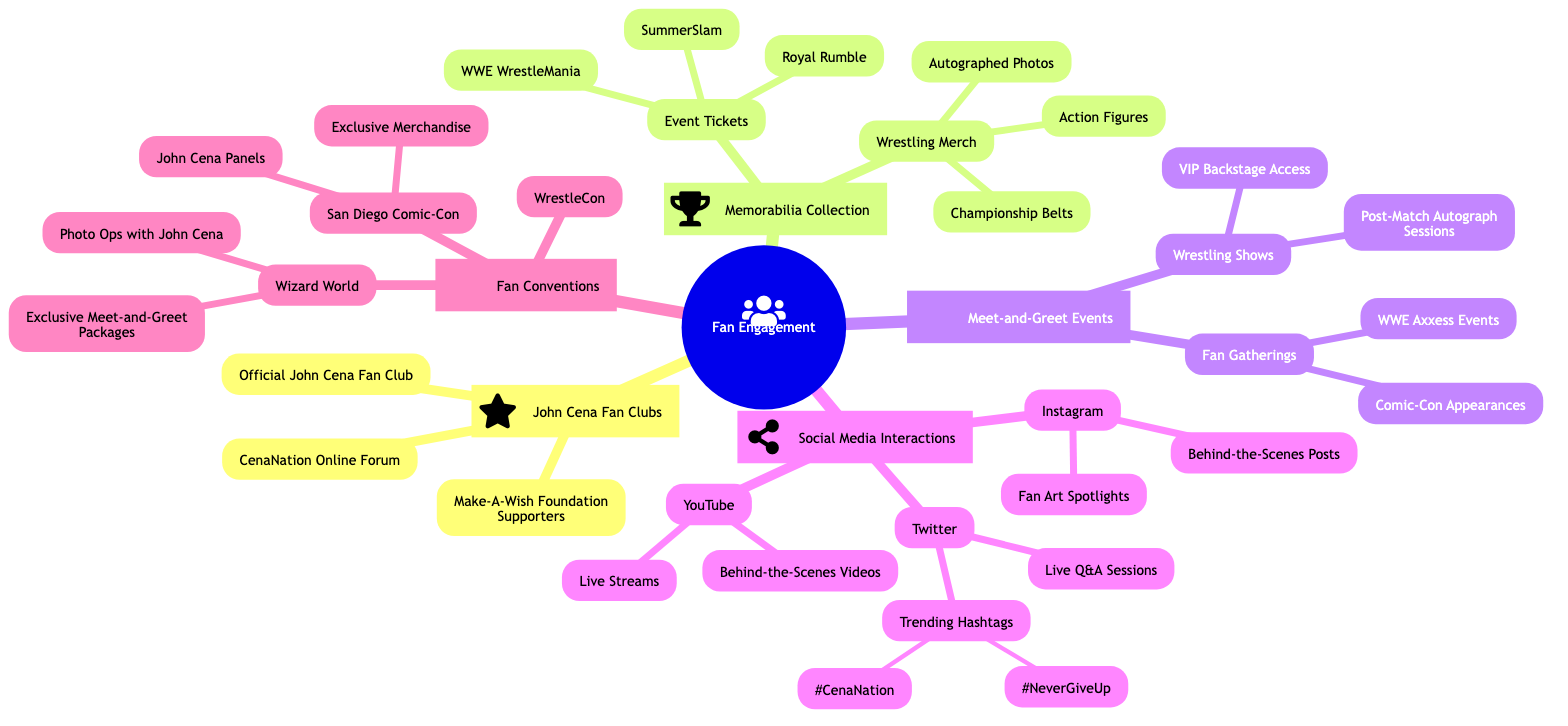What fan clubs are listed under John Cena? The diagram shows three fan clubs under the John Cena category. They are the Official John Cena Fan Club, Make-A-Wish Foundation Supporters, and CenaNation Online Forum. This can be identified by tracing from the main node "John Cena Fan Clubs" which branches out to these three nodes.
Answer: Official John Cena Fan Club, Make-A-Wish Foundation Supporters, CenaNation Online Forum How many types of memorabilia are listed? In the memorabilia section, there are two major categories: Wrestling Merch and Event Tickets. Each of these categories contains subcategories, but the distinct types of memorabilia are limited to these two. Hence, counting the main categories gives us the answer.
Answer: 2 What social media platform has the most interaction types? By analyzing the social media interactions section, we see that Twitter lists Live Q&A Sessions and Trending Hashtags, while Instagram has two distinct interaction types, and YouTube also has two. Therefore, Twitter has more variations compared to others.
Answer: Twitter Which event includes VIP Backstage Access? The diagram indicates that VIP Backstage Access is part of the Wrestling Shows under the Meet-and-Greet Events category. This can be determined by following the branches from the "Meet-and-Greet Events" which then leads down to "Wrestling Shows."
Answer: Wrestling Shows What are the trending hashtags listed? The specific hashtags in the Trending Hashtags section, found under Twitter, are #CenaNation and #NeverGiveUp. This information is contained in the last sub-node of the Twitter section.
Answer: #CenaNation, #NeverGiveUp How many events are included under Event Tickets? Under the Event Tickets category, there are three listed events: WWE WrestleMania, SummerSlam, and Royal Rumble. Counting these nodes gives us the total number of events in this section.
Answer: 3 What type of social media interaction is featured on Instagram? The diagram notes two types of interactions under Instagram: Behind-the-Scenes Posts and Fan Art Spotlights. Both of these are nested within the Instagram section, allowing easy identification.
Answer: Behind-the-Scenes Posts, Fan Art Spotlights Which convention has exclusive John Cena merchandise? The San Diego Comic-Con is mentioned to have Exclusive Merchandise under its section. It can be clearly identified under the Fan Conventions branch leading to conventions such as Wizard World and WrestleCon that do not have this specific type of merchandise.
Answer: San Diego Comic-Con How many meet-and-greet options are under Fan Gatherings? Within the Fan Gatherings category, there are two meet-and-greet options: Comic-Con Appearances and WWE Axxess Events. They can be counted directly from their respective node under Meet-and-Greet Events.
Answer: 2 